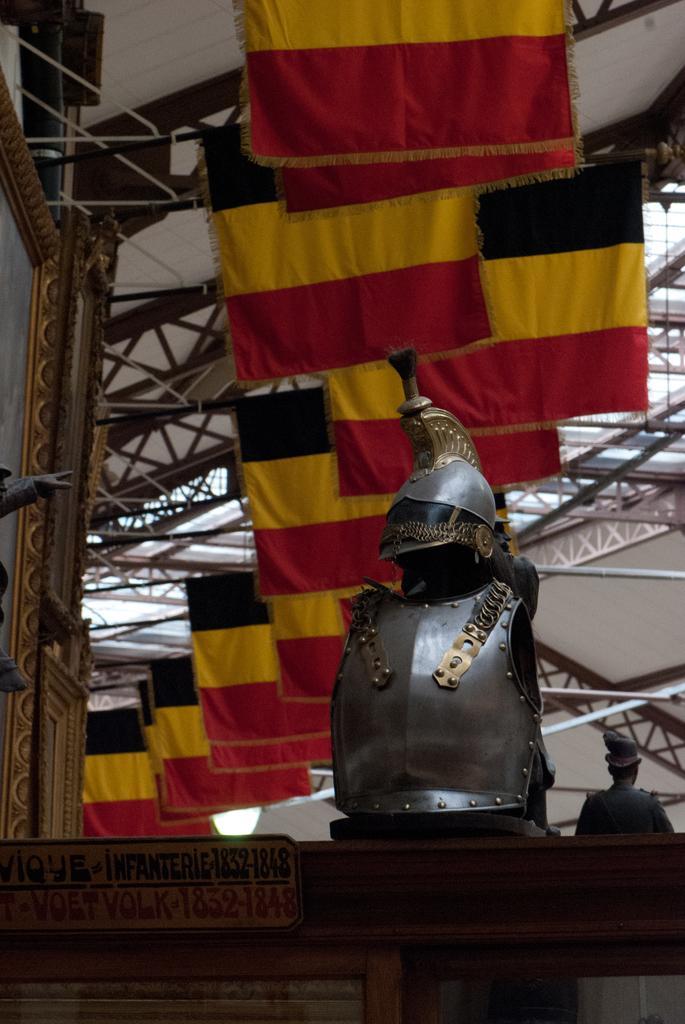In one or two sentences, can you explain what this image depicts? In this image I can see there is an Armour, few flags, metal rods to the ceiling. And there is a statue and a light. 